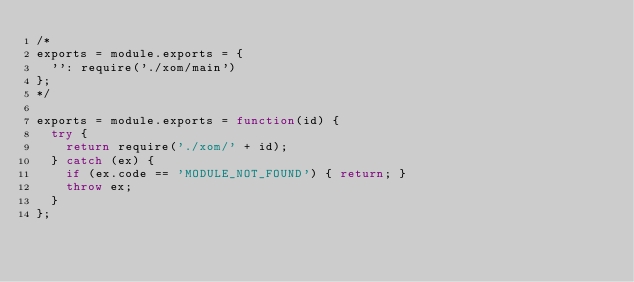<code> <loc_0><loc_0><loc_500><loc_500><_JavaScript_>/*
exports = module.exports = {
  '': require('./xom/main')
};
*/

exports = module.exports = function(id) {
  try {
    return require('./xom/' + id);
  } catch (ex) {
    if (ex.code == 'MODULE_NOT_FOUND') { return; }
    throw ex;
  }
};
</code> 